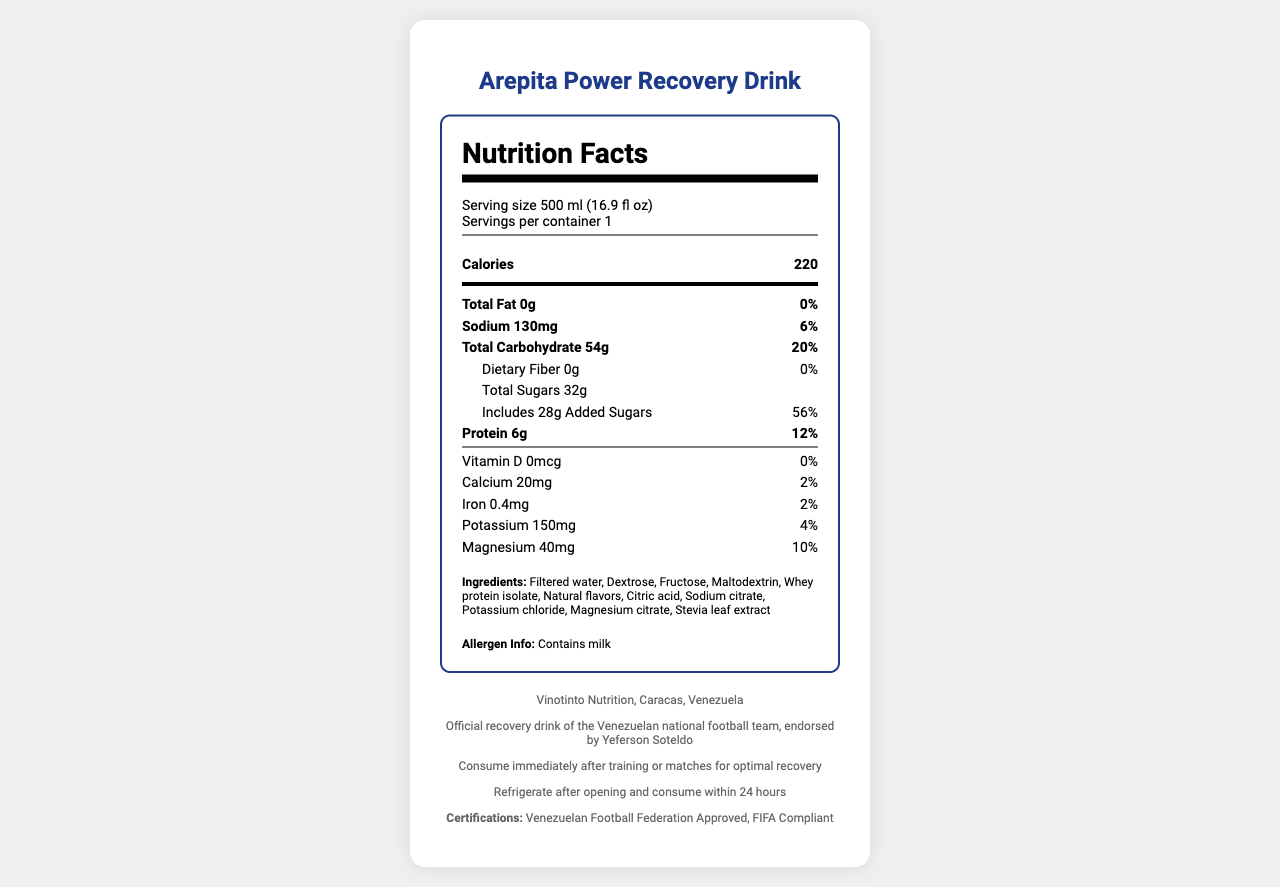what is the product name? The product name is prominently displayed at the top of the document.
Answer: Arepita Power Recovery Drink how many calories are in one serving? The calorie amount is listed directly next to the word "Calories" in the nutrition facts section.
Answer: 220 what is the serving size? The serving size is noted below the product name in the nutrition facts section.
Answer: 500 ml (16.9 fl oz) how much sodium does the drink contain? The sodium content is listed under the Total Fat information in the nutrition facts section.
Answer: 130mg what is the main protein source in the ingredients? The ingredients list shows "Whey protein isolate" as one of the ingredients.
Answer: Whey protein isolate which vitamins and minerals are present in the drink? A. Vitamin C, Calcium B. Vitamin D, Iron C. Calcium, Magnesium D. Iron, Vitamin K According to the nutrition facts, calcium and magnesium are listed with their amounts and daily values.
Answer: C. Calcium, Magnesium how much of the daily value for added sugars does the drink provide? A. 20% B. 40% C. 56% D. 70% The document indicates that the daily value for added sugars is 56%.
Answer: C. 56% does the drink contain milk? The allergen information clearly states that the drink contains milk.
Answer: Yes is the drink suitable for people with lactose intolerance? The drink contains whey protein isolate which includes milk, a common allergen for people with lactose intolerance.
Answer: No describe the main purpose of the document. This summary includes the most important parts of the document: its name, nutritional content, basic serving and product details, and additional usage and storage instructions.
Answer: The document is a detailed nutritional fact sheet for the Arepita Power Recovery Drink, including ingredients, nutritional content, allergen information, manufacturer details, and usage instructions aimed at users for post-training recovery. what is the manufacture location of the drink? The manufacturer section at the bottom of the document mentions that it is produced by Vinotinto Nutrition in Caracas, Venezuela.
Answer: Caracas, Venezuela who endorses the Arepita Power Recovery Drink? The product description section mentions that the drink is endorsed by Yeferson Soteldo.
Answer: Yeferson Soteldo what certifications does the drink hold? The document lists these certifications in the footer section.
Answer: Venezuelan Football Federation Approved, FIFA Compliant what is the total amount of dietary fiber in one serving? The dietary fiber amount is listed under the Total Carbohydrate information in the nutrition facts section.
Answer: 0g how many servings are there per container? The serving information mentions that there is 1 serving per container.
Answer: 1 which ingredient acts as a sweetener in the drink? The ingredients list includes "Stevia leaf extract," which is commonly used as a sweetener.
Answer: Stevia leaf extract what type of protein is used in the drink? A. Soy Protein B. Whey Protein Isolate C. Casein Protein D. Pea Protein According to the ingredients list, Whey Protein Isolate is used.
Answer: B. Whey Protein Isolate is the drink compliant with FIFA regulations? The certifications section states it is "FIFA Compliant."
Answer: Yes what are the storage instructions? The storage instructions are clearly stated in the footer section of the document.
Answer: Refrigerate after opening and consume within 24 hours what is the amount of potassium in the drink? The potassium content is listed in the nutrition facts section.
Answer: 150mg who is the target audience of the drink? While this is implied by the endorsements and certifications, it is directly stated in the product description that it is the official recovery drink of the Venezuelan national football team.
Answer: Venezuelan national football team players is there enough information to determine the exact amount of vitamin C in the drink? The nutrition facts only specify contents such as vitamin D, calcium, iron, potassium, and magnesium. Vitamin C is not mentioned.
Answer: Not enough information 